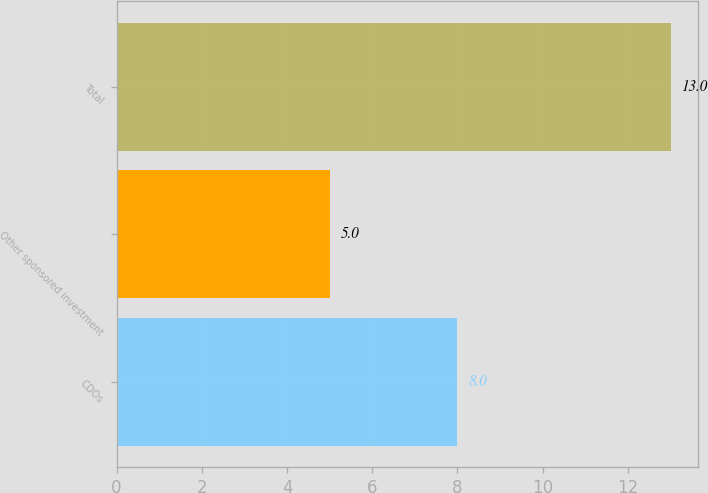<chart> <loc_0><loc_0><loc_500><loc_500><bar_chart><fcel>CDOs<fcel>Other sponsored investment<fcel>Total<nl><fcel>8<fcel>5<fcel>13<nl></chart> 